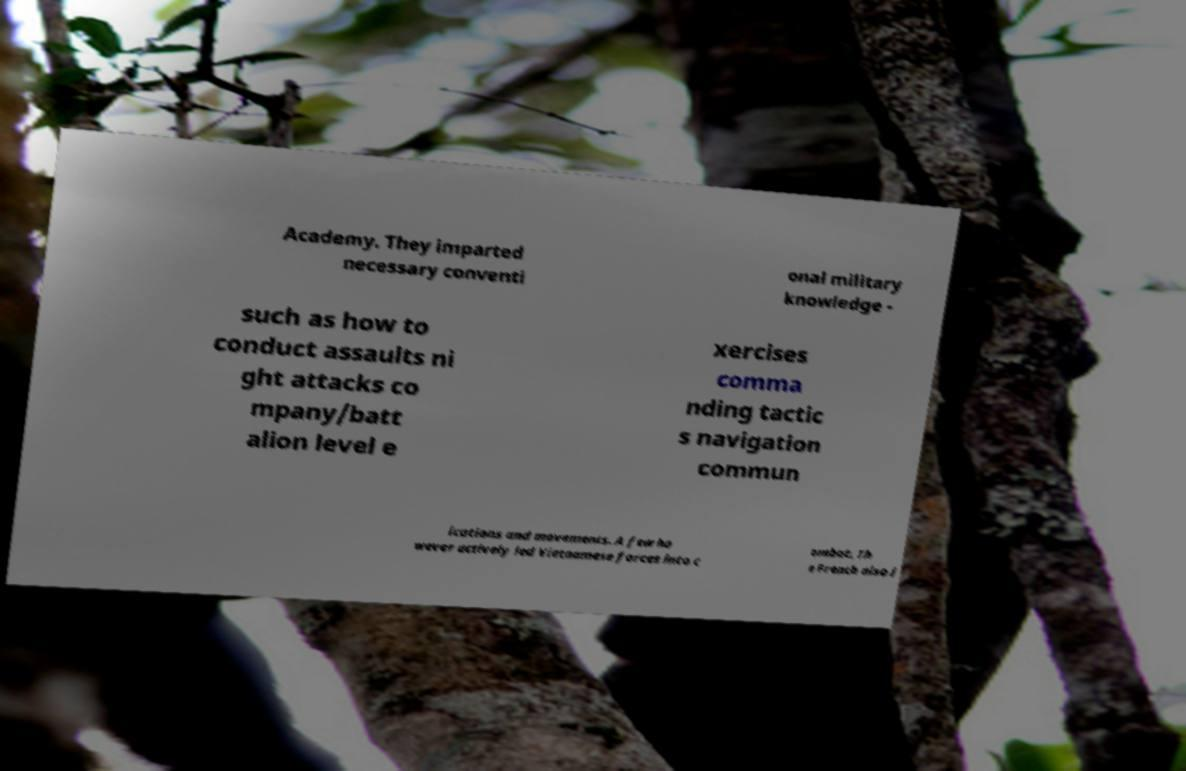Could you extract and type out the text from this image? Academy. They imparted necessary conventi onal military knowledge - such as how to conduct assaults ni ght attacks co mpany/batt alion level e xercises comma nding tactic s navigation commun ications and movements. A few ho wever actively led Vietnamese forces into c ombat. Th e French also i 